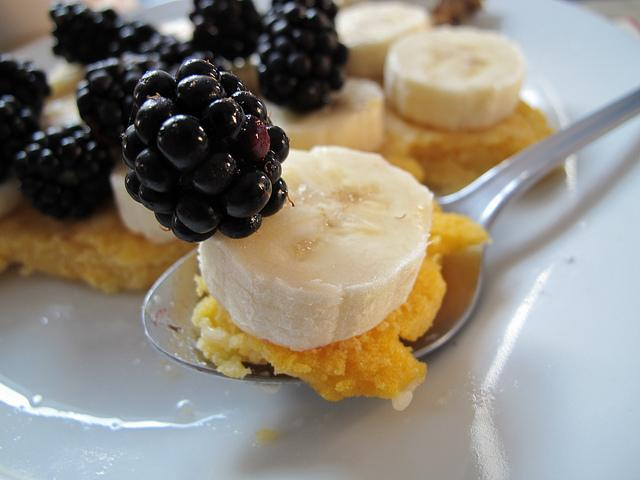What type of fruit is at the very top of the scoop with the banana and oat? blackberry 